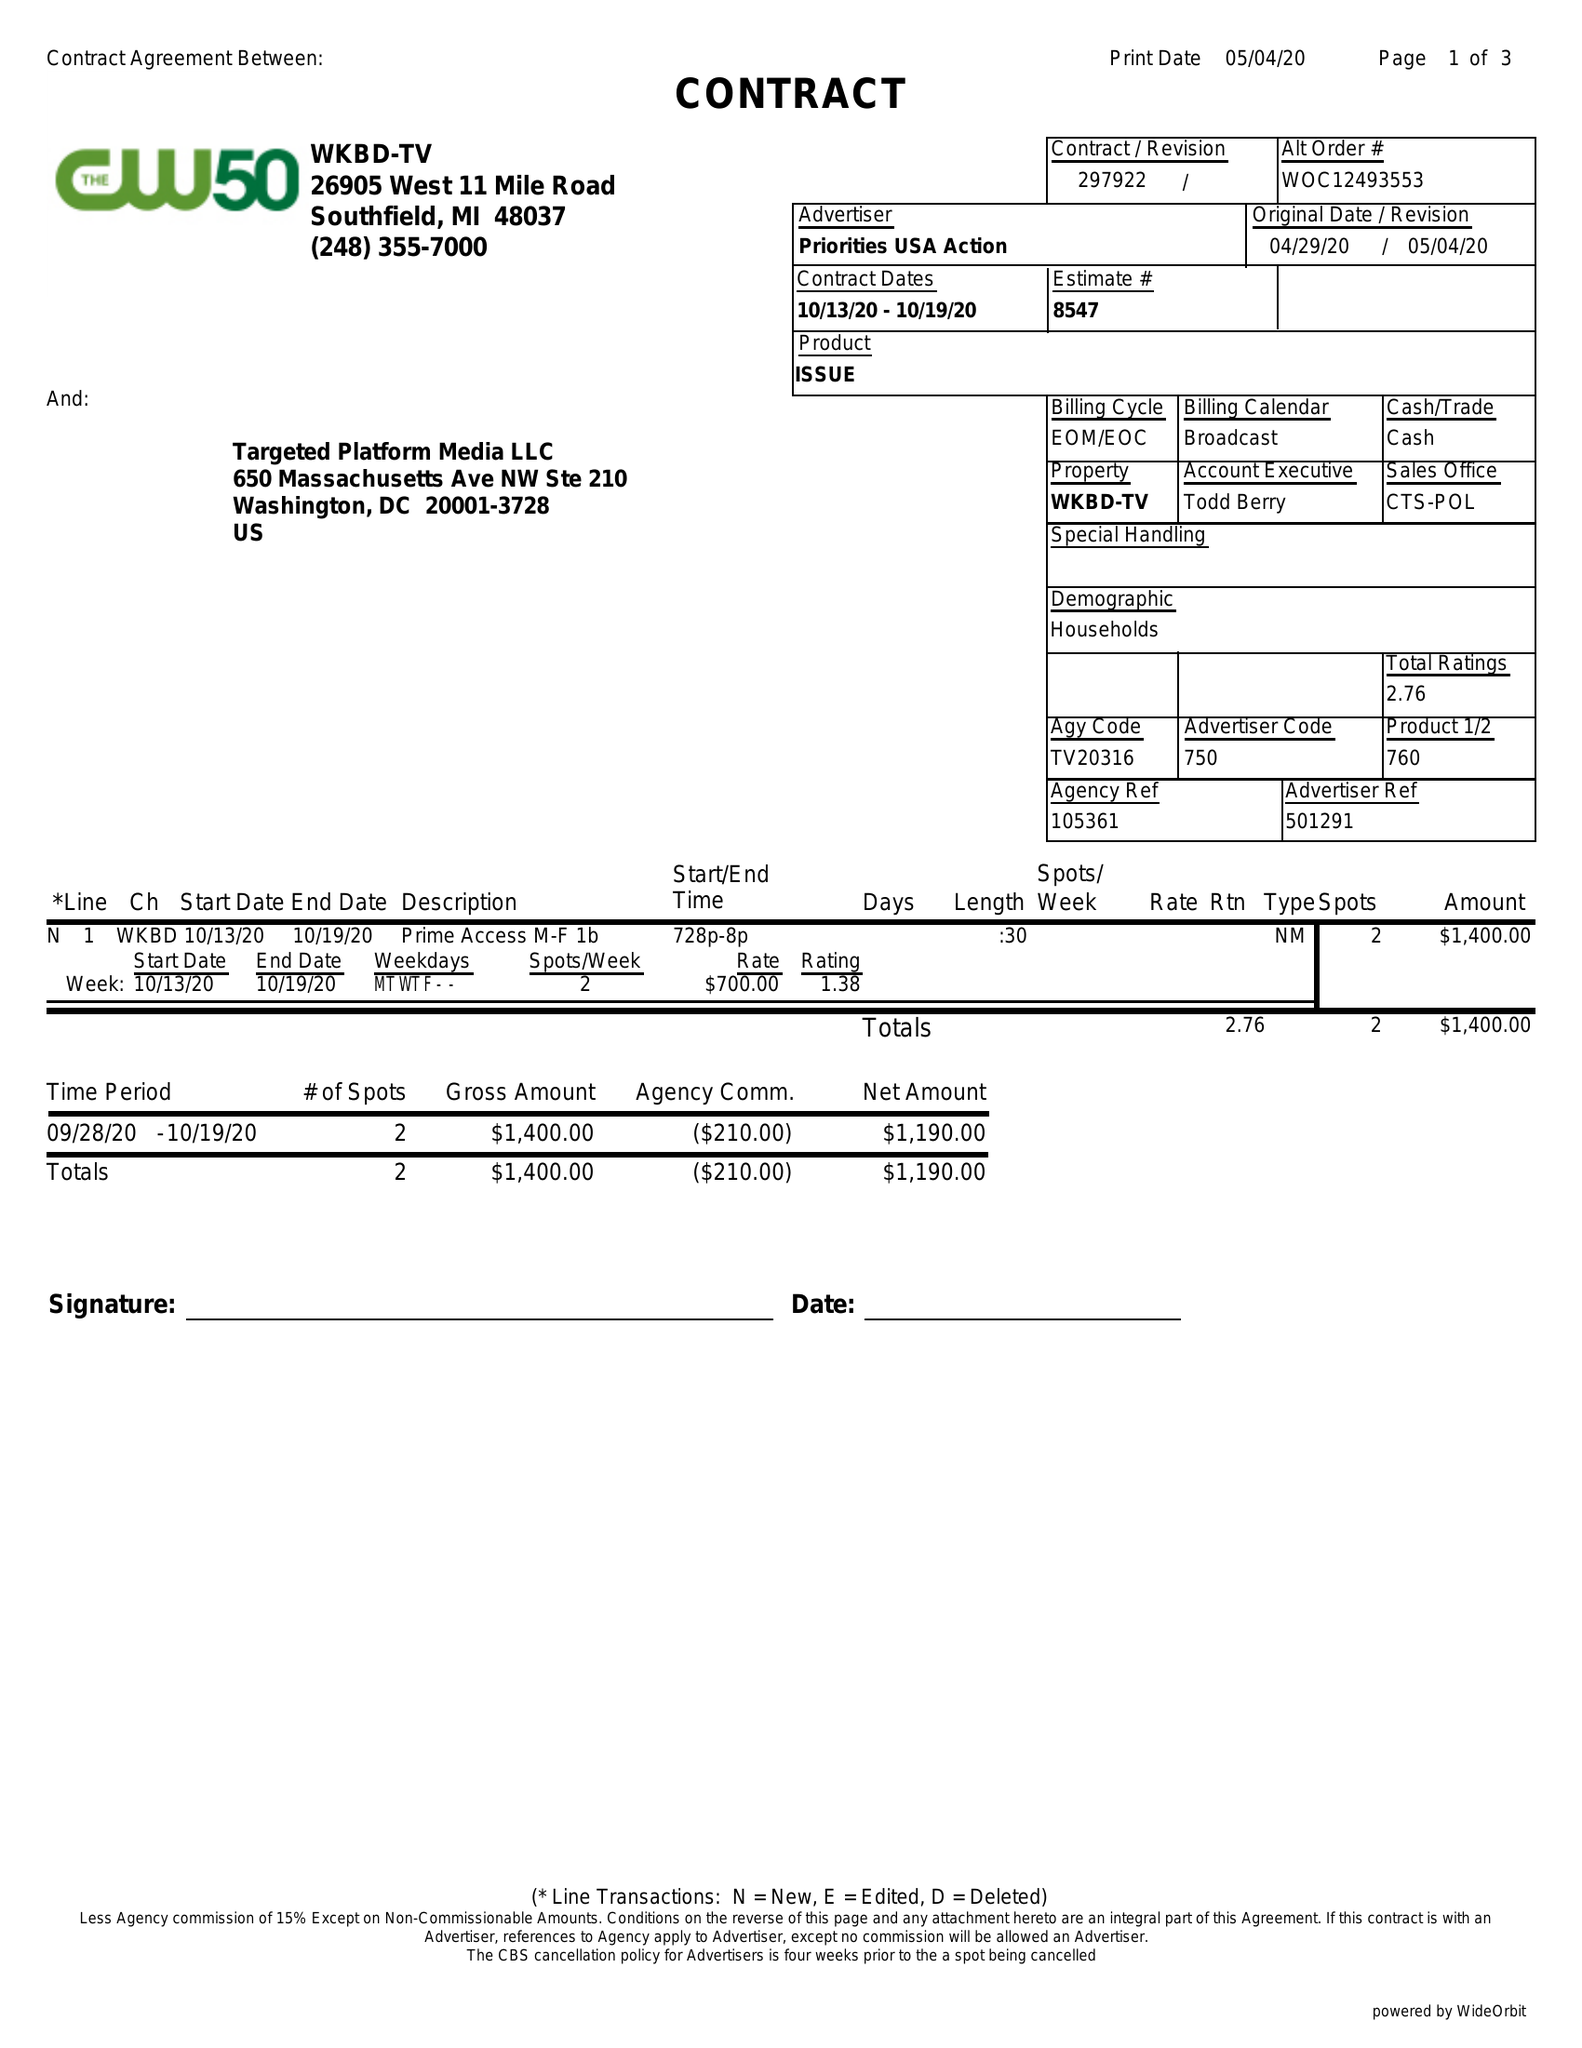What is the value for the flight_to?
Answer the question using a single word or phrase. 10/19/20 